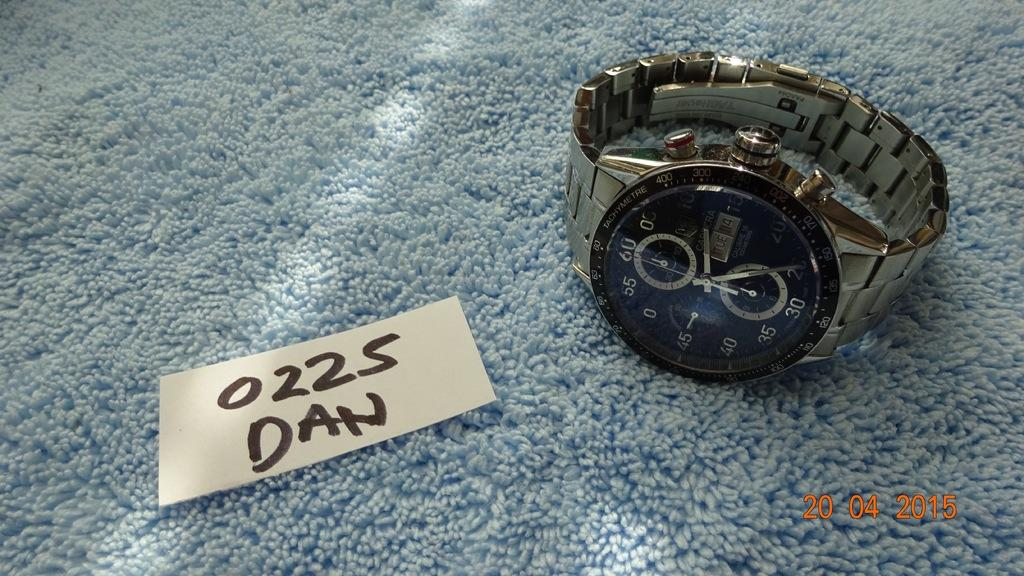<image>
Relay a brief, clear account of the picture shown. A note next to a watch reads 0225 Dan. 